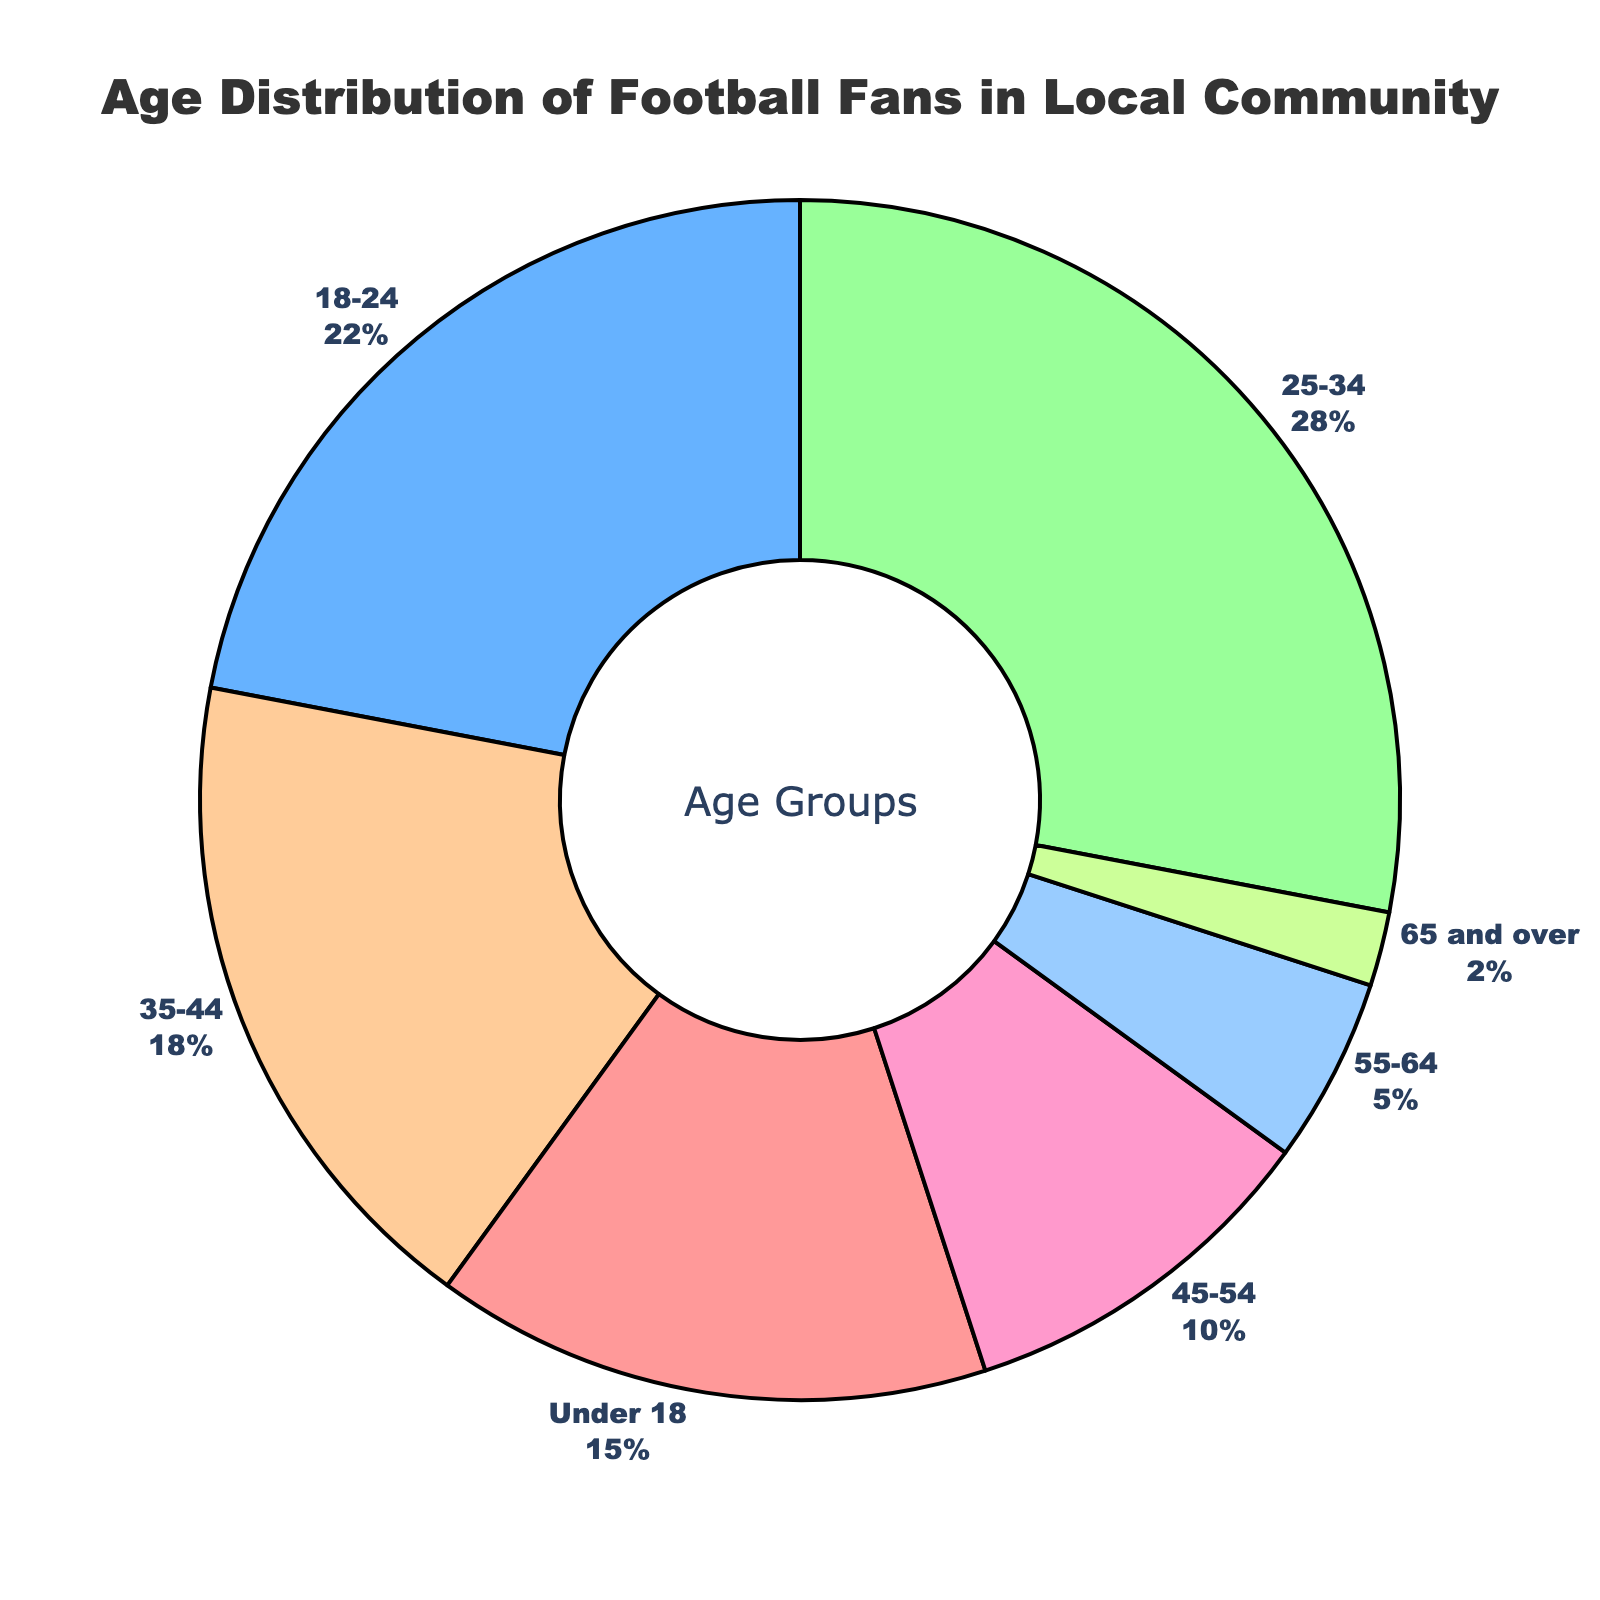what is the most represented age group? The slice of the pie chart with the largest percentage label represents the most represented age group. The label "25-34" has the highest percentage, 28%.
Answer: 25-34 how much larger is the 25-34 age group compared to the 55-64 age group? The percentage of the 25-34 age group is 28%, and the 55-64 age group is 5%. Subtracting these gives 28% - 5% = 23%.
Answer: 23% which two age groups together constitute over 40% of the distribution? Adding the percentages of different age groups, 25-34 and 18-24 yield 28% + 22% = 50%, which is over 40%.
Answer: 25-34 and 18-24 what is the sum of the percentages for all age groups under 35? Adding the percentages for Under 18, 18-24, and 25-34 gives 15% + 22% + 28% = 65%.
Answer: 65% which age group has the smallest percentage? The smallest slice in the pie chart represents the smallest percentage. The label "65 and over" has the smallest percentage, 2%.
Answer: 65 and over how does the 45-54 age group's percentage compare to the 35-44 age group's? The percentage for 35-44 is 18%, and for 45-54 is 10%. The 35-44 age group is 18% - 10% = 8% higher than the 45-54 age group.
Answer: 8% higher which age group is represented by a green color in the chart? The text description mentions the order of colors, identifying the third slice's age group in order. The green color corresponds to the "25-34" age group.
Answer: 25-34 how much more represented is the age group of 25-34 compared to all age groups over 54 combined? The percentage for 25-34 is 28%. Adding the percentages for 55-64 and 65 and over gives 5% + 2% = 7%. The 25-34 age group is 28% - 7% = 21% more represented.
Answer: 21% more represented what percentage of the community is 45 years and older? Summing the percentages for age groups 45-54, 55-64, and 65 and over gives 10% + 5% + 2% = 17%.
Answer: 17% 